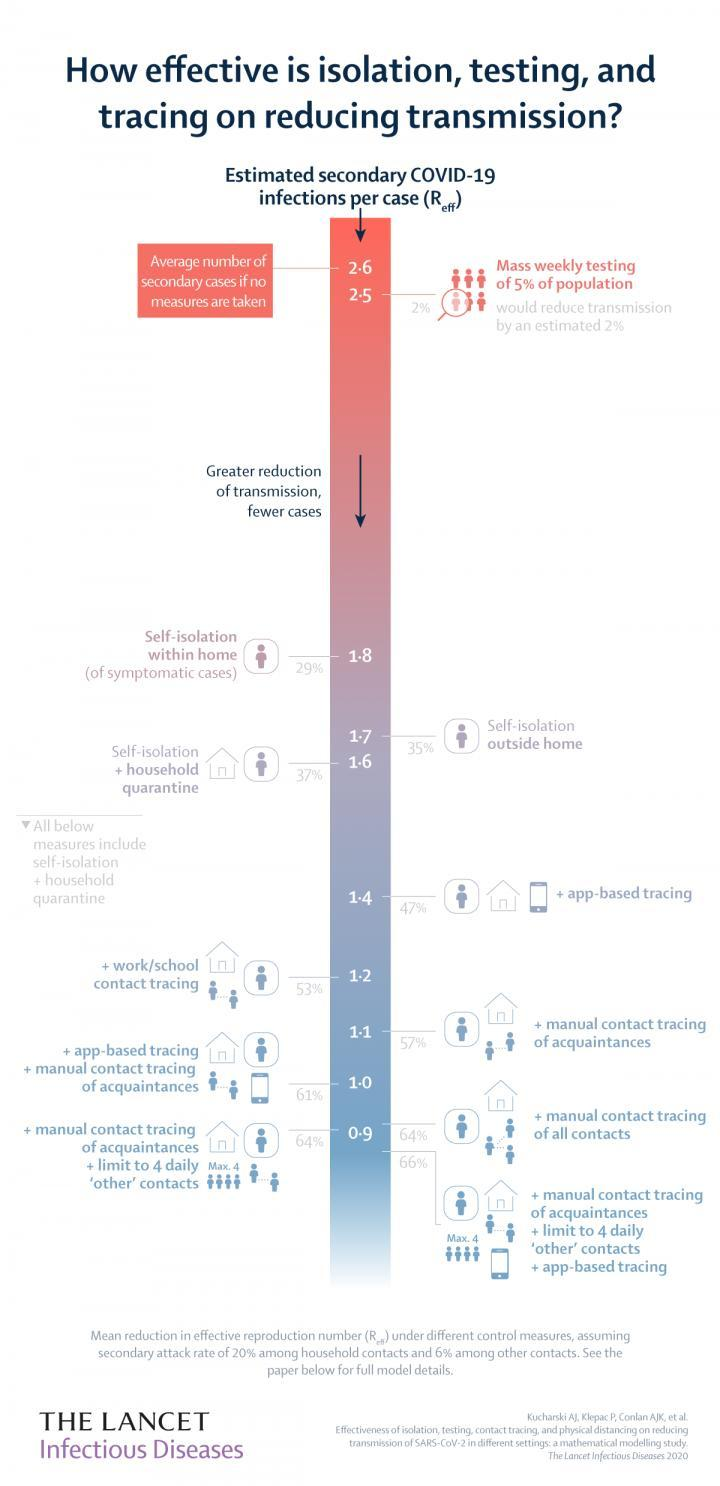List a handful of essential elements in this visual. According to estimates, if symptomatic individuals self-isolate and are placed under household quarantine, the secondary COVID-19 infections per case could be as low as 1.6. According to estimates, self-isolation done outside the home could potentially reduce the transmission of COVID-19 by approximately 35%. A study has estimated that implementing self isolation along with household quarantine could lead to a 37% reduction in the transmission of COVID-19. It is estimated that, on average, approximately 1.8 secondary COVID-19 infections occur for every case where symptomatic individuals self-isolate within their homes. The estimated secondary COVID-19 infections per case if self-isolation is done outside the home is 1.7. 